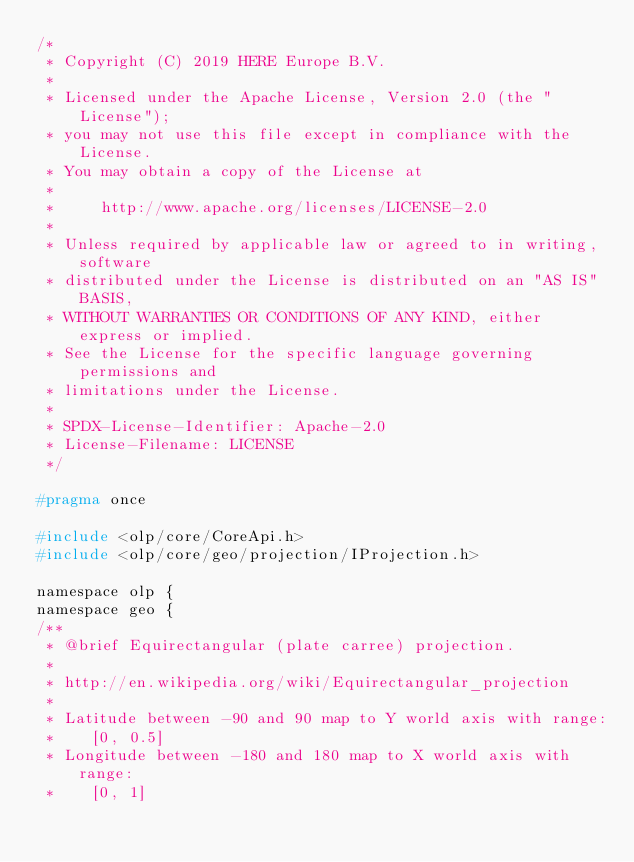Convert code to text. <code><loc_0><loc_0><loc_500><loc_500><_C_>/*
 * Copyright (C) 2019 HERE Europe B.V.
 *
 * Licensed under the Apache License, Version 2.0 (the "License");
 * you may not use this file except in compliance with the License.
 * You may obtain a copy of the License at
 *
 *     http://www.apache.org/licenses/LICENSE-2.0
 *
 * Unless required by applicable law or agreed to in writing, software
 * distributed under the License is distributed on an "AS IS" BASIS,
 * WITHOUT WARRANTIES OR CONDITIONS OF ANY KIND, either express or implied.
 * See the License for the specific language governing permissions and
 * limitations under the License.
 *
 * SPDX-License-Identifier: Apache-2.0
 * License-Filename: LICENSE
 */

#pragma once

#include <olp/core/CoreApi.h>
#include <olp/core/geo/projection/IProjection.h>

namespace olp {
namespace geo {
/**
 * @brief Equirectangular (plate carree) projection.
 *
 * http://en.wikipedia.org/wiki/Equirectangular_projection
 *
 * Latitude between -90 and 90 map to Y world axis with range:
 *    [0, 0.5]
 * Longitude between -180 and 180 map to X world axis with range:
 *    [0, 1]</code> 